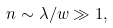Convert formula to latex. <formula><loc_0><loc_0><loc_500><loc_500>n \sim \lambda / w \gg 1 ,</formula> 